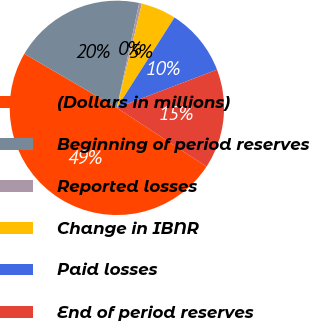Convert chart. <chart><loc_0><loc_0><loc_500><loc_500><pie_chart><fcel>(Dollars in millions)<fcel>Beginning of period reserves<fcel>Reported losses<fcel>Change in IBNR<fcel>Paid losses<fcel>End of period reserves<nl><fcel>49.18%<fcel>19.92%<fcel>0.41%<fcel>5.29%<fcel>10.16%<fcel>15.04%<nl></chart> 